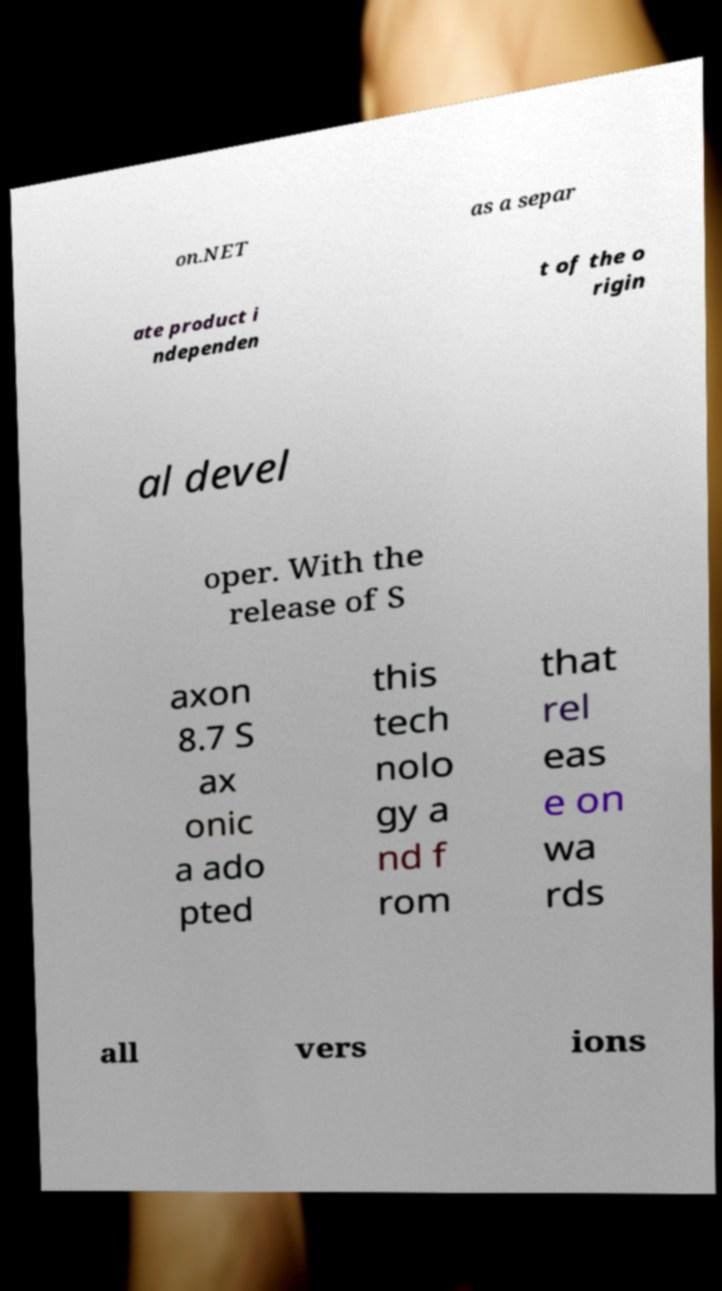Can you accurately transcribe the text from the provided image for me? on.NET as a separ ate product i ndependen t of the o rigin al devel oper. With the release of S axon 8.7 S ax onic a ado pted this tech nolo gy a nd f rom that rel eas e on wa rds all vers ions 